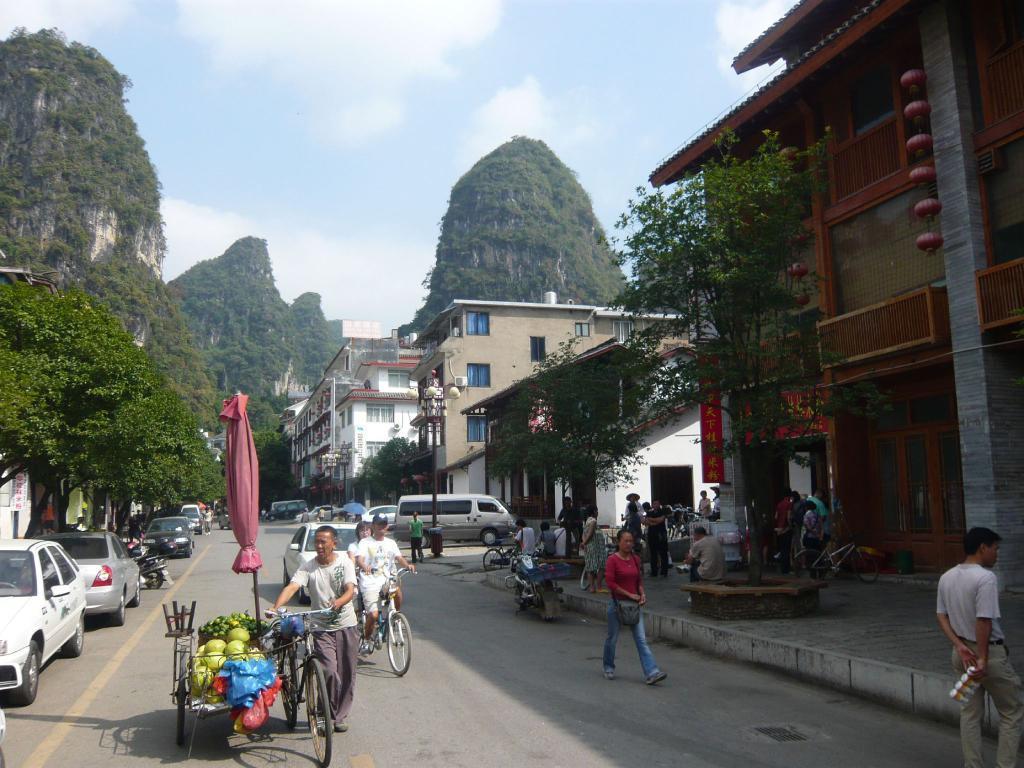Describe this image in one or two sentences. In this picture there are people and we can see vehicles on the road. We can see fruits on a cart, trees, pole, lights and buildings. In the background of the image we can see hills and sky with clouds. 